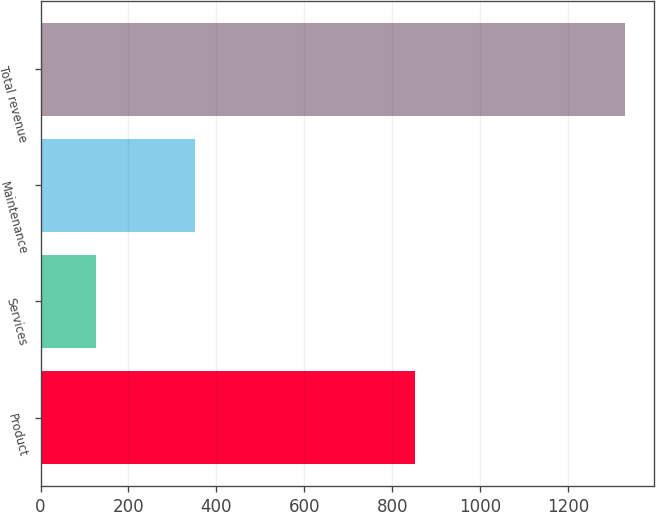Convert chart to OTSL. <chart><loc_0><loc_0><loc_500><loc_500><bar_chart><fcel>Product<fcel>Services<fcel>Maintenance<fcel>Total revenue<nl><fcel>851.5<fcel>126.2<fcel>351.5<fcel>1329.2<nl></chart> 